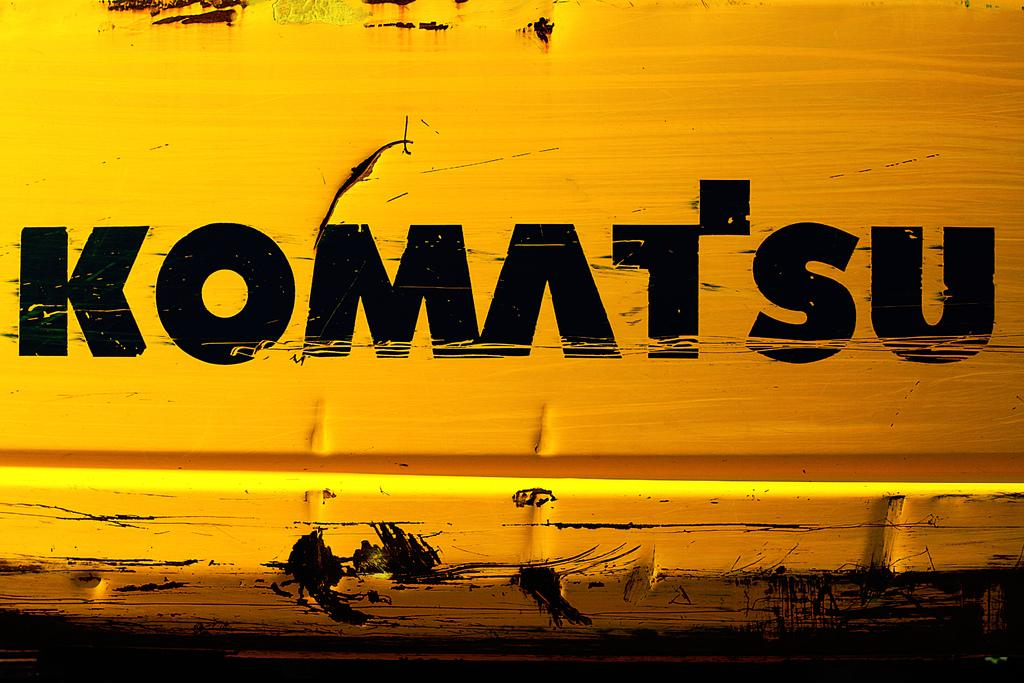<image>
Provide a brief description of the given image. A close up of a piece of yellow equipment made by Komatsu. 